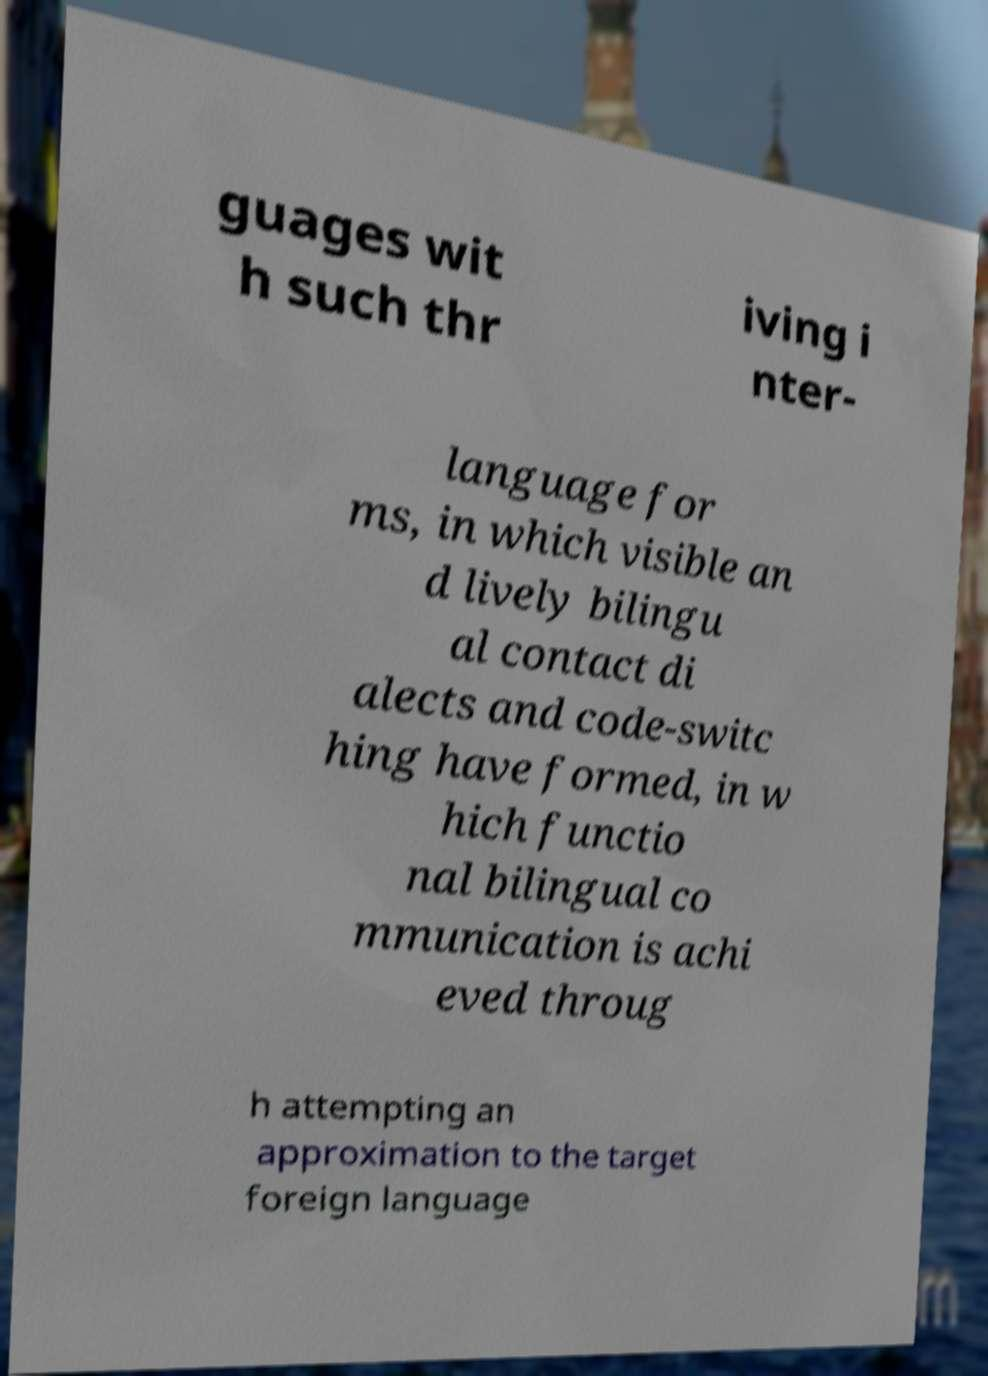Please identify and transcribe the text found in this image. guages wit h such thr iving i nter- language for ms, in which visible an d lively bilingu al contact di alects and code-switc hing have formed, in w hich functio nal bilingual co mmunication is achi eved throug h attempting an approximation to the target foreign language 